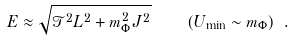Convert formula to latex. <formula><loc_0><loc_0><loc_500><loc_500>E \approx \sqrt { { \mathcal { T } } ^ { 2 } L ^ { 2 } + m _ { \Phi } ^ { 2 } J ^ { 2 } } \quad ( U _ { \min } \sim m _ { \Phi } ) \ .</formula> 